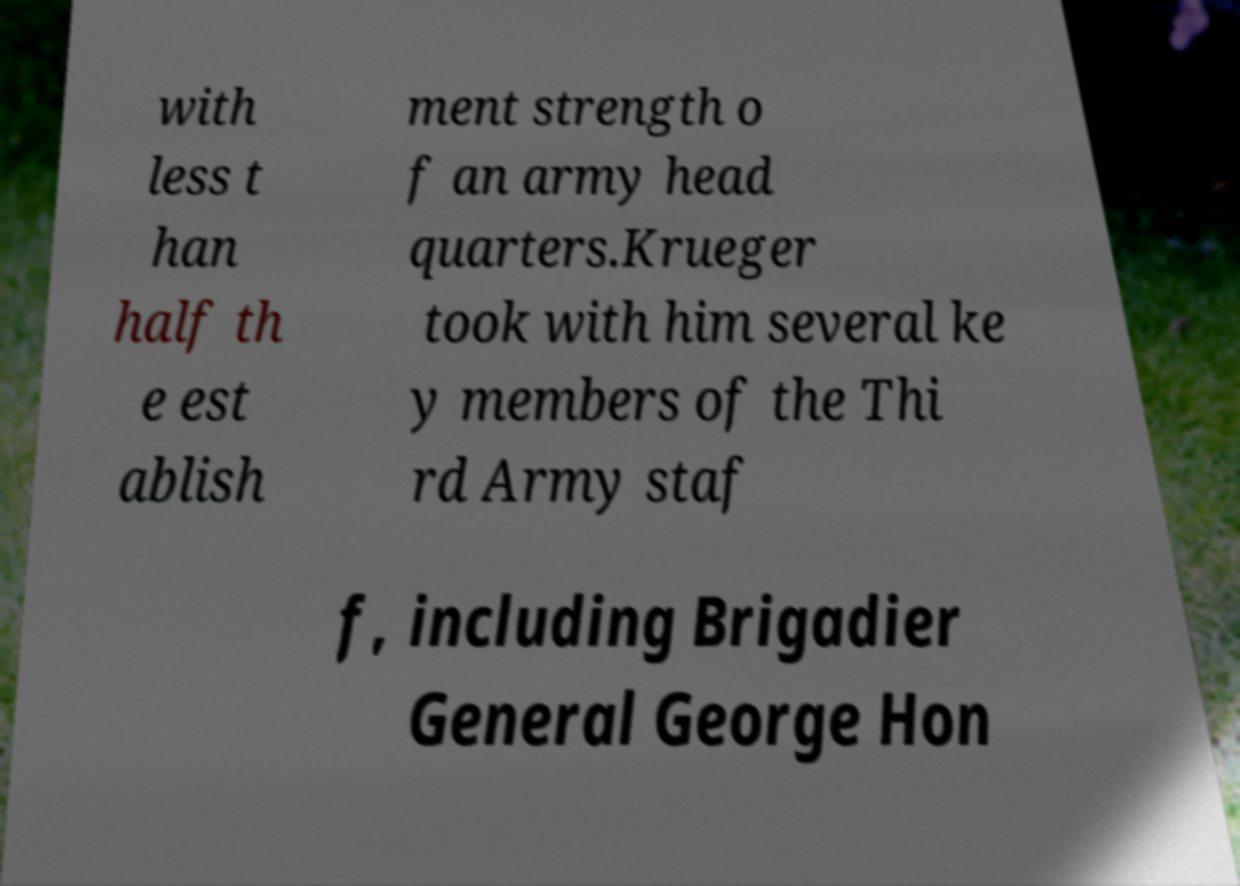Can you read and provide the text displayed in the image?This photo seems to have some interesting text. Can you extract and type it out for me? with less t han half th e est ablish ment strength o f an army head quarters.Krueger took with him several ke y members of the Thi rd Army staf f, including Brigadier General George Hon 